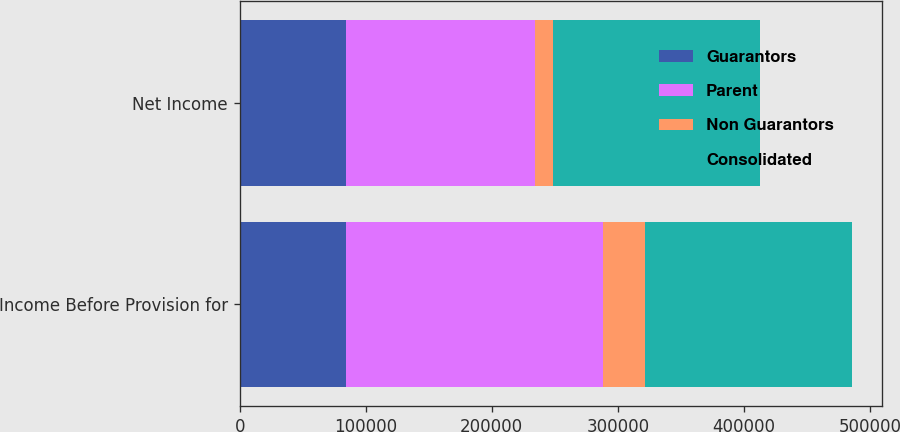Convert chart to OTSL. <chart><loc_0><loc_0><loc_500><loc_500><stacked_bar_chart><ecel><fcel>Income Before Provision for<fcel>Net Income<nl><fcel>Guarantors<fcel>84637<fcel>84637<nl><fcel>Parent<fcel>203378<fcel>149929<nl><fcel>Non Guarantors<fcel>33241<fcel>14338<nl><fcel>Consolidated<fcel>164267<fcel>164267<nl></chart> 